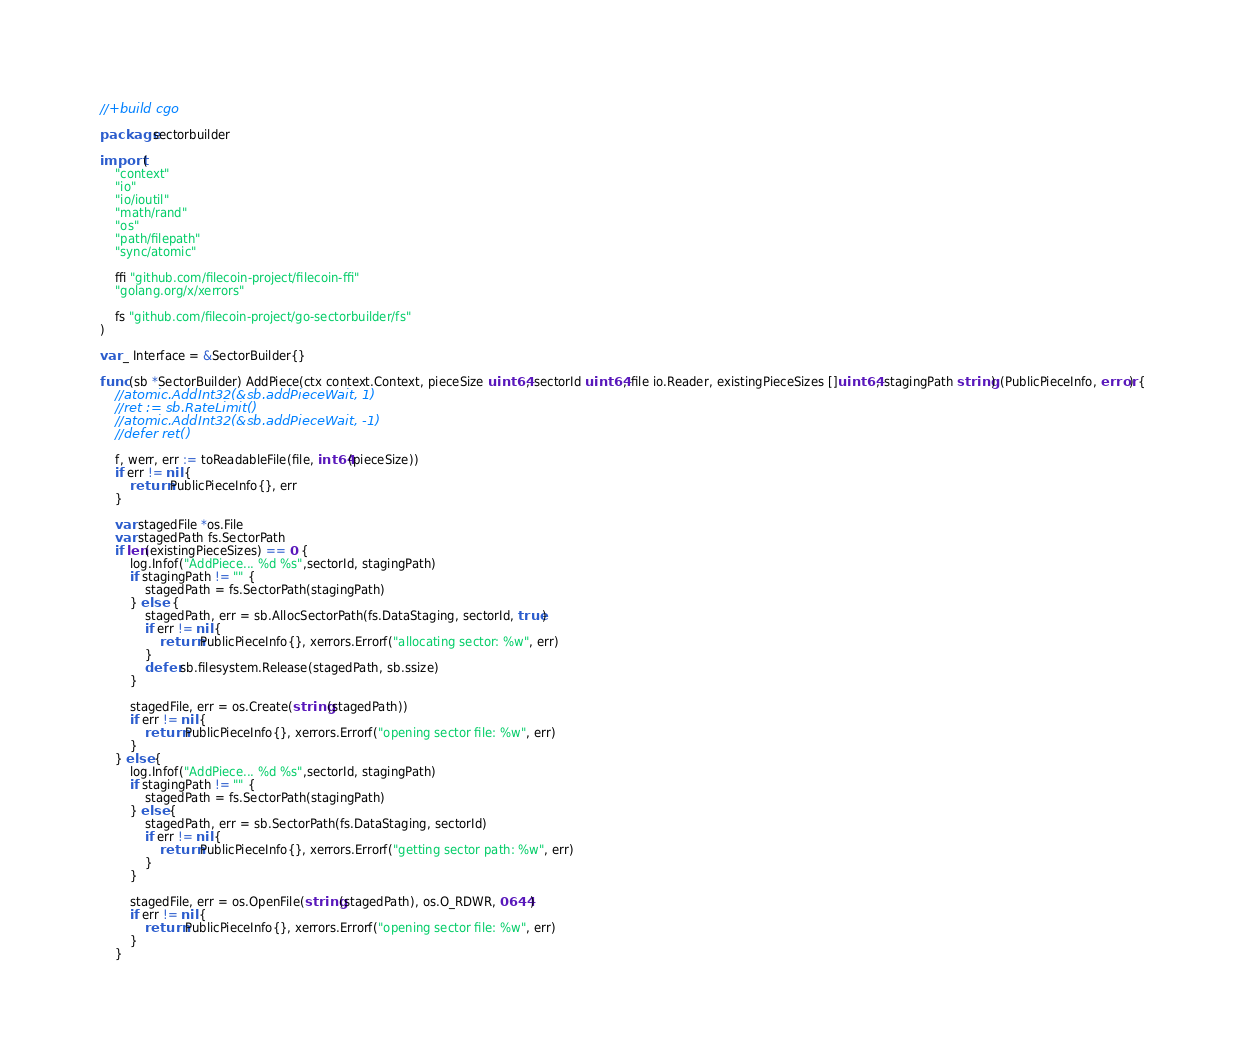<code> <loc_0><loc_0><loc_500><loc_500><_Go_>//+build cgo

package sectorbuilder

import (
	"context"
	"io"
	"io/ioutil"
	"math/rand"
	"os"
	"path/filepath"
	"sync/atomic"

	ffi "github.com/filecoin-project/filecoin-ffi"
	"golang.org/x/xerrors"

	fs "github.com/filecoin-project/go-sectorbuilder/fs"
)

var _ Interface = &SectorBuilder{}

func (sb *SectorBuilder) AddPiece(ctx context.Context, pieceSize uint64, sectorId uint64, file io.Reader, existingPieceSizes []uint64, stagingPath string) (PublicPieceInfo, error) {
	//atomic.AddInt32(&sb.addPieceWait, 1)
	//ret := sb.RateLimit()
	//atomic.AddInt32(&sb.addPieceWait, -1)
	//defer ret()

	f, werr, err := toReadableFile(file, int64(pieceSize))
	if err != nil {
		return PublicPieceInfo{}, err
	}

	var stagedFile *os.File
	var stagedPath fs.SectorPath
	if len(existingPieceSizes) == 0 {
		log.Infof("AddPiece... %d %s",sectorId, stagingPath)
		if stagingPath != "" {
			stagedPath = fs.SectorPath(stagingPath)
		} else  {
			stagedPath, err = sb.AllocSectorPath(fs.DataStaging, sectorId, true)
			if err != nil {
				return PublicPieceInfo{}, xerrors.Errorf("allocating sector: %w", err)
			}
			defer sb.filesystem.Release(stagedPath, sb.ssize)
		}

		stagedFile, err = os.Create(string(stagedPath))
		if err != nil {
			return PublicPieceInfo{}, xerrors.Errorf("opening sector file: %w", err)
		}
	} else {
		log.Infof("AddPiece... %d %s",sectorId, stagingPath)
		if stagingPath != "" {
			stagedPath = fs.SectorPath(stagingPath)
		} else {
			stagedPath, err = sb.SectorPath(fs.DataStaging, sectorId)
			if err != nil {
				return PublicPieceInfo{}, xerrors.Errorf("getting sector path: %w", err)
			}
		}

		stagedFile, err = os.OpenFile(string(stagedPath), os.O_RDWR, 0644)
		if err != nil {
			return PublicPieceInfo{}, xerrors.Errorf("opening sector file: %w", err)
		}
	}
</code> 